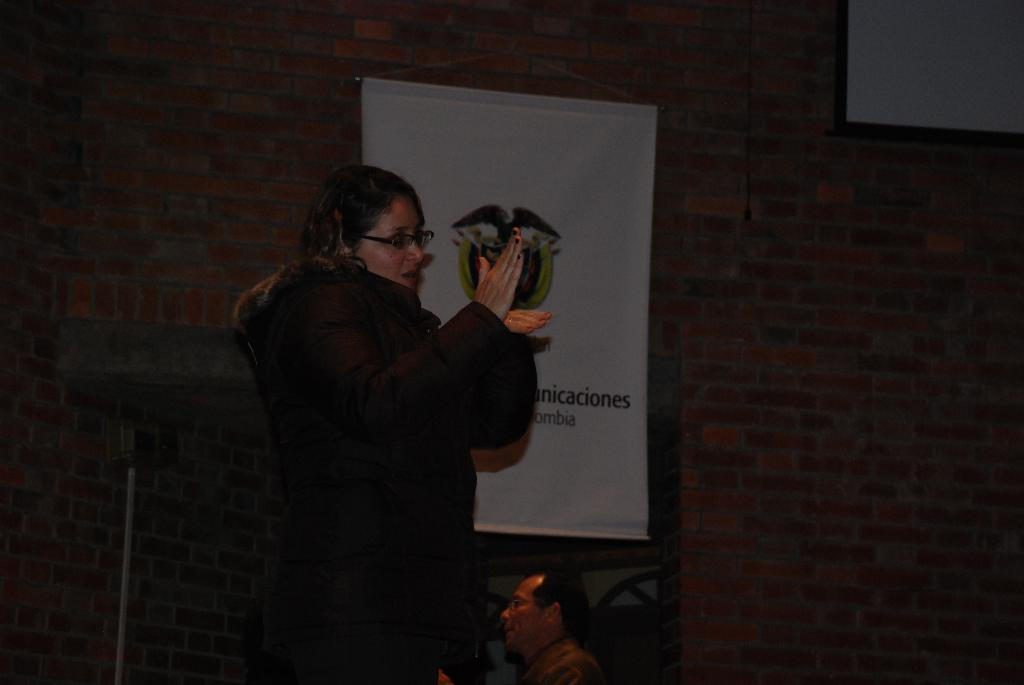What is the main subject of the image? There is a person standing in the image. Can you describe the person's attire? The person is wearing clothes. What is on the wall in the image? There is a banner on the wall in the image. What can be found on the banner? The banner contains a logo and some text. Are there any other people in the image? Yes, there is another person at the bottom of the image. How is the distribution of fowl managed in the image? There is no mention of fowl or distribution in the image; it primarily features a person and a banner. What type of hands are visible on the person in the image? The image does not show the person's hands, so it cannot be determined what type of hands they have. 